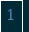<code> <loc_0><loc_0><loc_500><loc_500><_PHP_>
</code> 